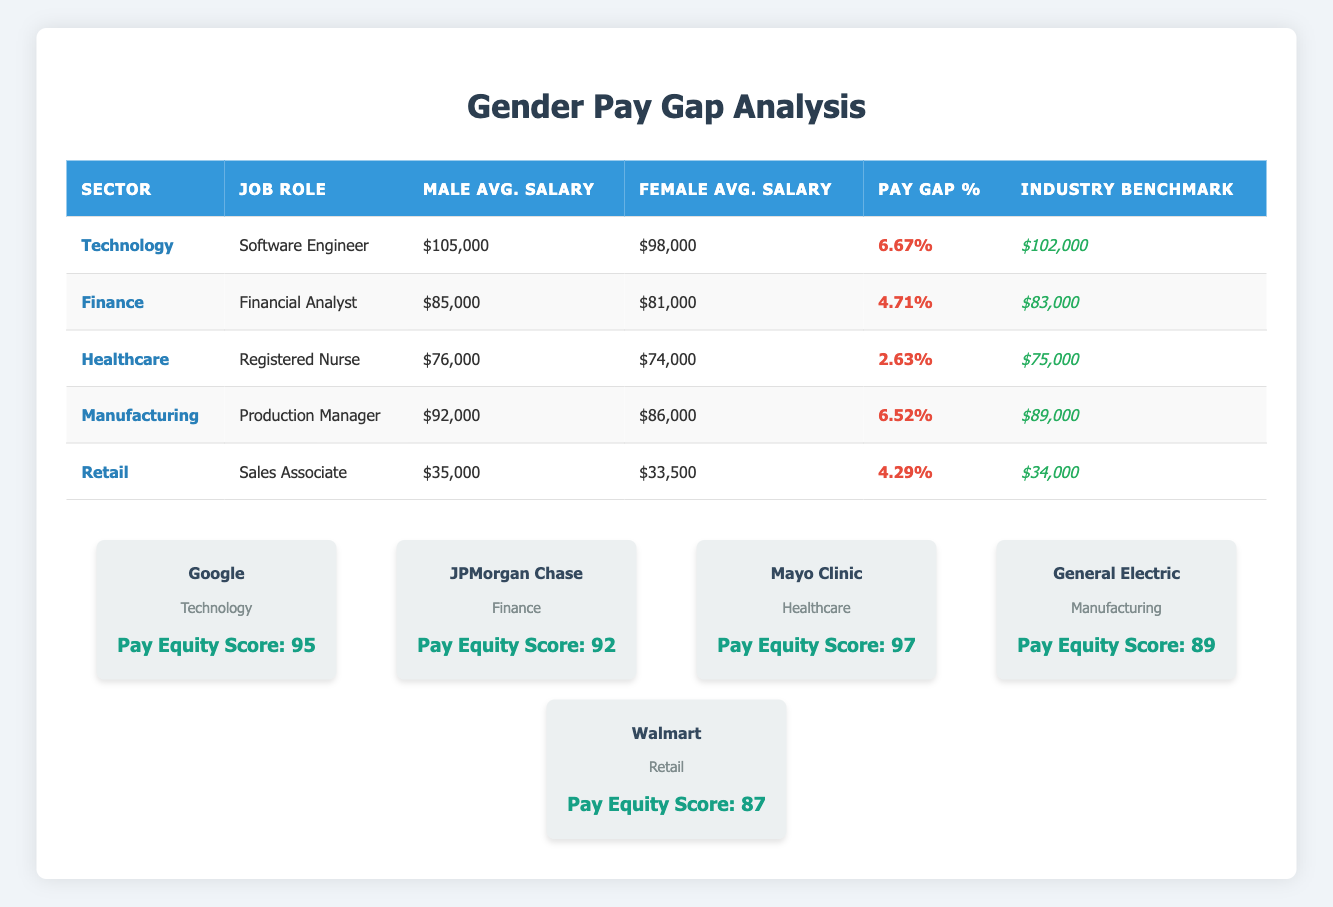What is the average male salary for the Technology sector? The male average salary for Software Engineers in the Technology sector is 105000. Therefore, the average male salary for that sector is 105000.
Answer: 105000 What is the pay gap percentage for the Healthcare sector? The pay gap percentage for Registered Nurses in the Healthcare sector is presented in the table as 2.63%.
Answer: 2.63% Which job role has the highest male average salary? By comparing the male average salaries across all job roles, Software Engineer (105000) has the highest salary, while others are lower.
Answer: Software Engineer Is the female average salary for the Production Manager role higher than 86000? The table shows the female average salary for Production Manager is 86000. Therefore, it is not higher than 86000.
Answer: No What is the total average salary of male employees in the Finance and Healthcare sectors? The male average salary for Financial Analysts is 85000, and for Registered Nurses is 76000. Adding these gives 85000 + 76000 = 161000.
Answer: 161000 In which sector does the job role "Sales Associate" fall, and what is the female average salary for that role? The Sales Associate role is in the Retail sector, with a female average salary of 33500 as given in the table.
Answer: Retail sector; 33500 Is the industry benchmark salary for Software Engineers higher than the female average salary for that role? The industry benchmark for Software Engineers is 102000, and the female average salary is 98000. Since 102000 is greater than 98000, the statement is true.
Answer: Yes Are males and females in the Healthcare sector paid equally based on their average salaries? The male average salary is 76000, and the female average salary is 74000, indicating a pay gap; therefore, they are not paid equally.
Answer: No What is the average pay gap percentage across all sectors listed in the table? To find the average pay gap percentage, add up all pay gaps: 6.67 + 4.71 + 2.63 + 6.52 + 4.29 = 24.82 and divide by the number of sectors (5): 24.82 / 5 = 4.964.
Answer: 4.96 